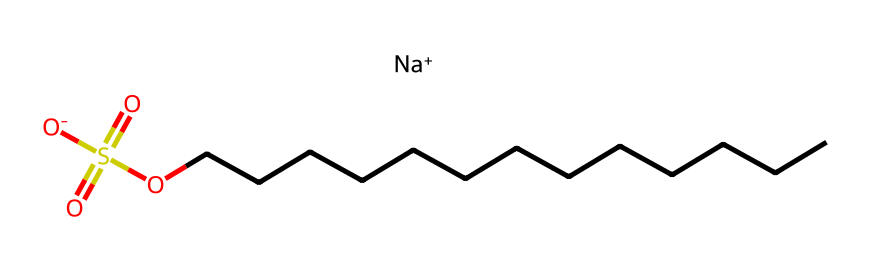What is the chemical name of the represented structure? The SMILES representation can be decoded to determine the name of the compound, which consists of a sodium ion, a sulfonate group, and a long hydrocarbon chain of dodecyl (12 carbon atoms). Hence, the chemical name is derived from these components.
Answer: sodium dodecyl sulfate How many carbon atoms are in the hydrocarbon chain? The SMILES shows the presence of a long chain (CCCCCCCCCCCCC) representing the hydrocarbon part, which corresponds to 13 carbon atoms in total following the standard notation.
Answer: 13 What type of ion is present in this surfactant? The SMILES contains the notation "[Na+]", which indicates the presence of a sodium ion, characteristic of many surfactants where a metal ion balances the anionic part of the structure.
Answer: sodium ion How many sulfur atoms are in the compound? The structure shows a 'S(=O)(=O)' section, indicating one sulfur atom with two double-bonded oxygen atoms, indicating that there is a single sulfur atom present in the entire structure.
Answer: 1 Does this surfactant have a hydrophilic or hydrophobic tail? The long carbon chain (CCCCCCCCCCCCC) is hydrophobic due to its non-polar nature, while the sulfonate group (S(=O)(=O)O) is hydrophilic. Therefore, the presence of a long hydrocarbon chain indicates a hydrophobic tail.
Answer: hydrophobic What is the role of the sulfonate group in this surfactant? The sulfonate group contains sulfur and oxygen atoms that are negatively charged (-SO3^-), making this end of the molecule hydrophilic, which allows the surfactant to interact with water and reduce surface tension, hence crucial for its function.
Answer: reduce surface tension 